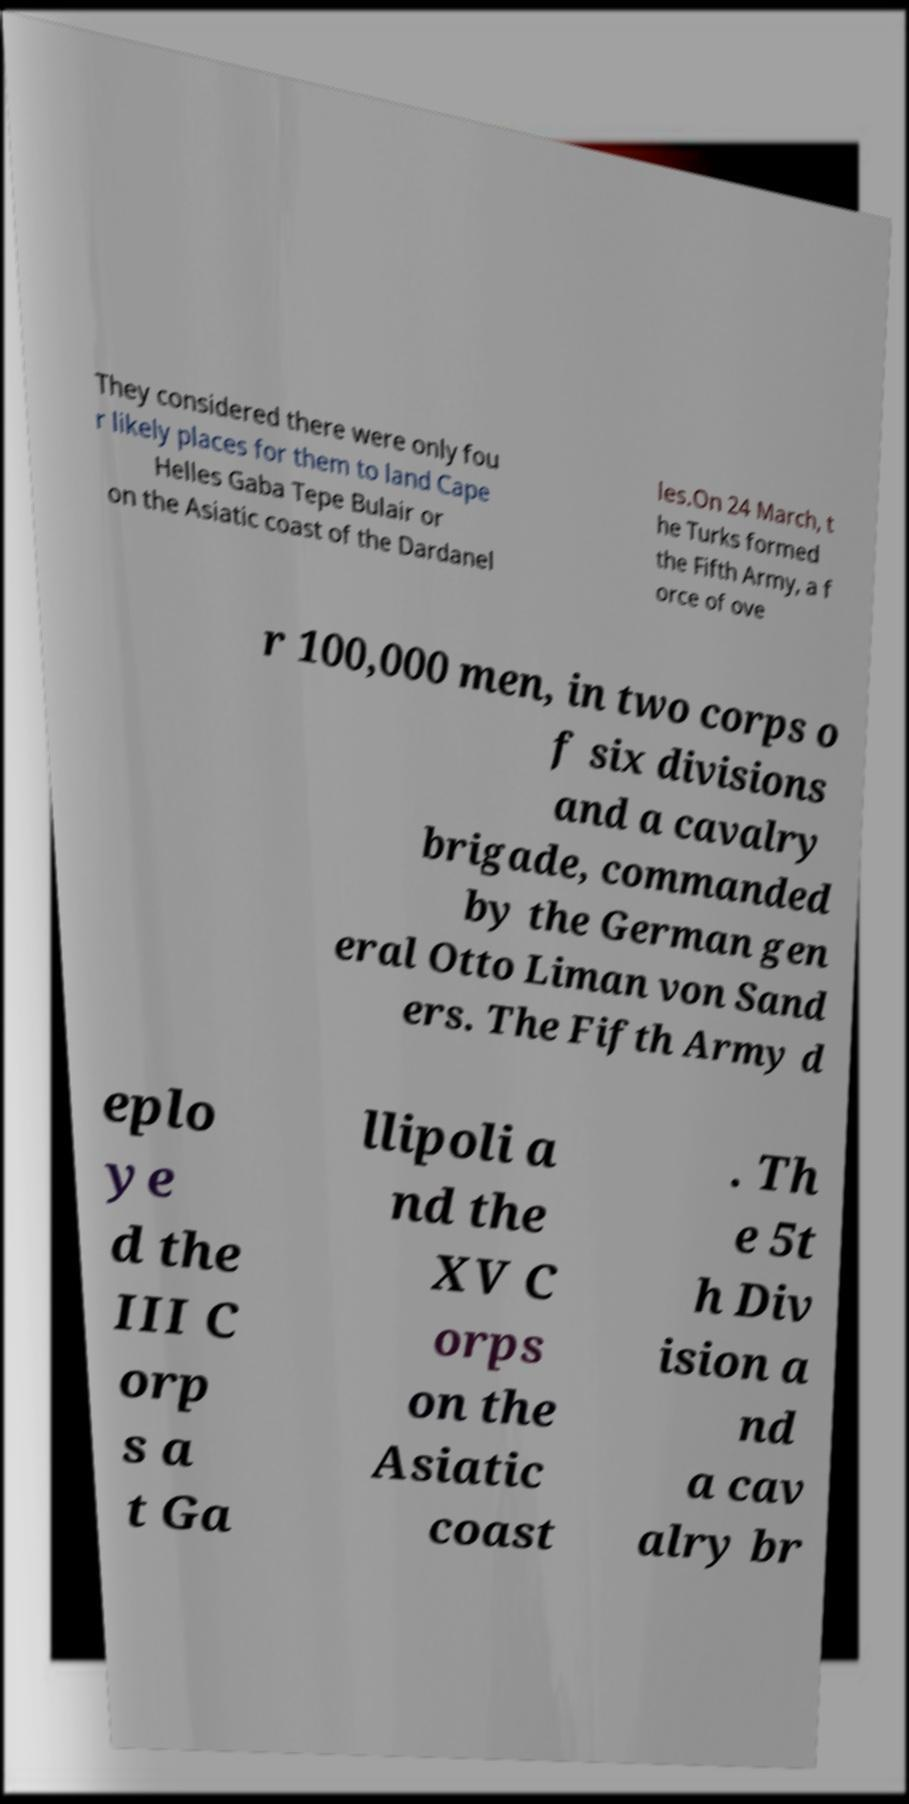Please identify and transcribe the text found in this image. They considered there were only fou r likely places for them to land Cape Helles Gaba Tepe Bulair or on the Asiatic coast of the Dardanel les.On 24 March, t he Turks formed the Fifth Army, a f orce of ove r 100,000 men, in two corps o f six divisions and a cavalry brigade, commanded by the German gen eral Otto Liman von Sand ers. The Fifth Army d eplo ye d the III C orp s a t Ga llipoli a nd the XV C orps on the Asiatic coast . Th e 5t h Div ision a nd a cav alry br 